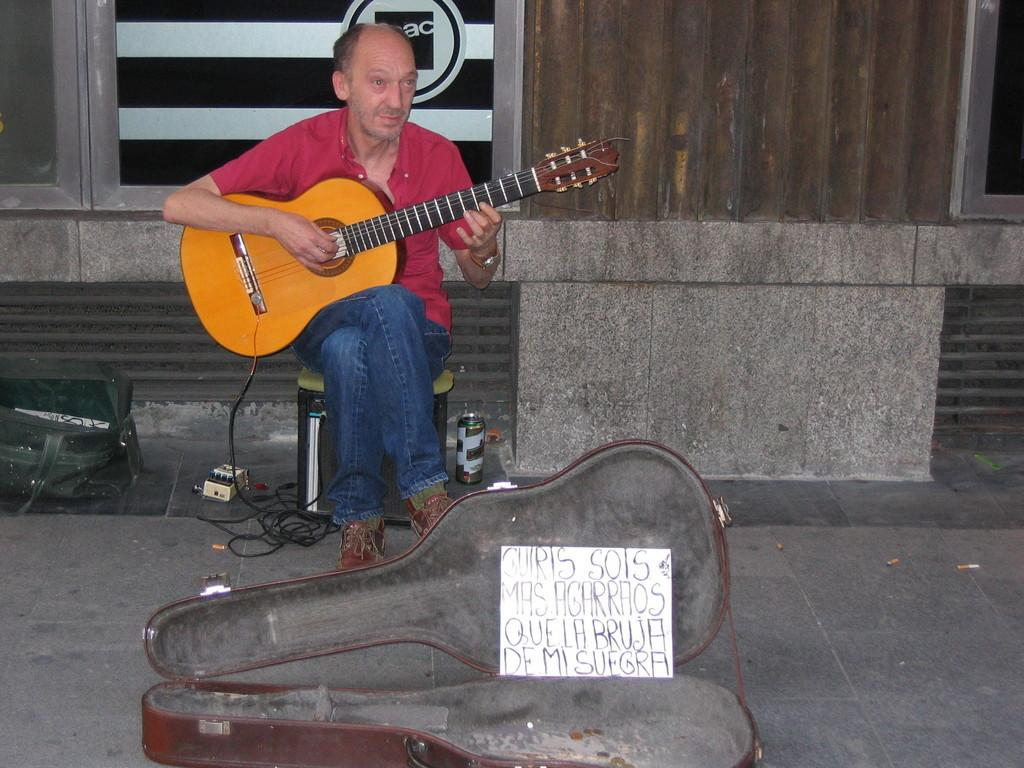What is the man in the image doing? The man is playing a guitar in the image. What is the man sitting on? The man is sitting on an object in the image. What is located on the ground near the man? There is a guitar box on the ground and a tin can in the image. What type of cart is the man using to transport the appliance in the image? There is no cart or appliance present in the image. 